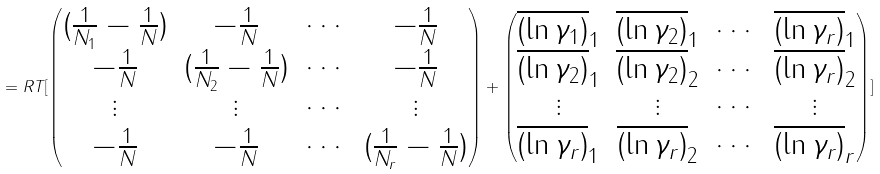Convert formula to latex. <formula><loc_0><loc_0><loc_500><loc_500>= R T [ \begin{pmatrix} ( \frac { 1 } { N _ { 1 } } - \frac { 1 } { N } ) & - \frac { 1 } { N } & \cdots & - \frac { 1 } { N } \\ - \frac { 1 } { N } & ( \frac { 1 } { N _ { 2 } } - \frac { 1 } { N } ) & \cdots & - \frac { 1 } { N } \\ \vdots & \vdots & \cdots & \vdots \\ - \frac { 1 } { N } & - \frac { 1 } { N } & \cdots & ( \frac { 1 } { N _ { r } } - \frac { 1 } { N } ) \end{pmatrix} + \begin{pmatrix} \overline { ( \ln { \gamma _ { 1 } } ) } _ { 1 } & \overline { ( \ln { \gamma _ { 2 } } ) } _ { 1 } & \cdots & \overline { ( \ln { \gamma _ { r } } ) } _ { 1 } \\ \overline { ( \ln { \gamma _ { 2 } } ) } _ { 1 } & \overline { ( \ln { \gamma _ { 2 } } ) } _ { 2 } & \cdots & \overline { ( \ln { \gamma _ { r } } ) } _ { 2 } \\ \vdots & \vdots & \cdots & \vdots \\ \overline { ( \ln { \gamma _ { r } } ) } _ { 1 } & \overline { ( \ln { \gamma _ { r } } ) } _ { 2 } & \cdots & \overline { ( \ln { \gamma _ { r } } ) } _ { r } \end{pmatrix} ]</formula> 